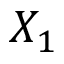<formula> <loc_0><loc_0><loc_500><loc_500>X _ { 1 }</formula> 